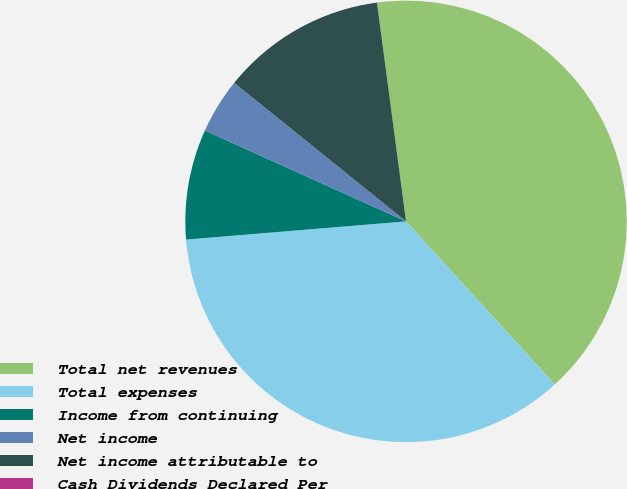Convert chart. <chart><loc_0><loc_0><loc_500><loc_500><pie_chart><fcel>Total net revenues<fcel>Total expenses<fcel>Income from continuing<fcel>Net income<fcel>Net income attributable to<fcel>Cash Dividends Declared Per<nl><fcel>40.33%<fcel>35.46%<fcel>8.07%<fcel>4.04%<fcel>12.1%<fcel>0.0%<nl></chart> 